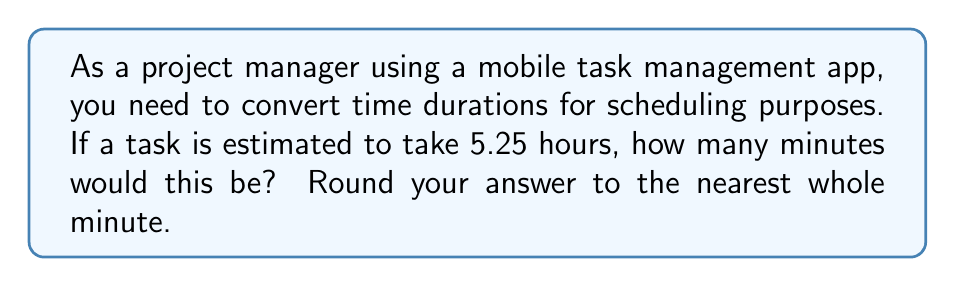Provide a solution to this math problem. To convert hours to minutes, we need to multiply the number of hours by 60 (since there are 60 minutes in one hour).

Let's break this down step-by-step:

1) We start with 5.25 hours.

2) Set up the conversion:
   $5.25 \text{ hours} \times \frac{60 \text{ minutes}}{1 \text{ hour}}$

3) Multiply:
   $5.25 \times 60 = 315$

4) The result is 315 minutes.

5) Since the question asks to round to the nearest whole minute, and 315 is already a whole number, no rounding is necessary.

This conversion allows you to input the task duration in minutes into your mobile task management app for more precise scheduling.
Answer: 315 minutes 